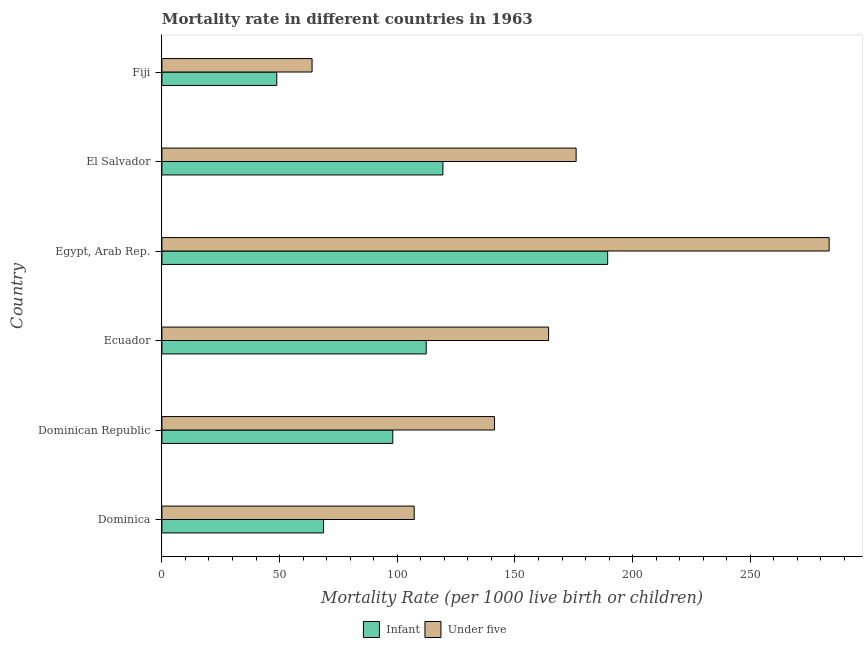How many different coloured bars are there?
Ensure brevity in your answer.  2. How many groups of bars are there?
Give a very brief answer. 6. How many bars are there on the 6th tick from the bottom?
Provide a short and direct response. 2. What is the label of the 1st group of bars from the top?
Provide a succinct answer. Fiji. In how many cases, is the number of bars for a given country not equal to the number of legend labels?
Provide a succinct answer. 0. What is the infant mortality rate in Egypt, Arab Rep.?
Ensure brevity in your answer.  189.4. Across all countries, what is the maximum infant mortality rate?
Your response must be concise. 189.4. Across all countries, what is the minimum under-5 mortality rate?
Your answer should be very brief. 63.8. In which country was the under-5 mortality rate maximum?
Your response must be concise. Egypt, Arab Rep. In which country was the under-5 mortality rate minimum?
Keep it short and to the point. Fiji. What is the total under-5 mortality rate in the graph?
Ensure brevity in your answer.  936.1. What is the difference between the infant mortality rate in Dominican Republic and that in Fiji?
Offer a very short reply. 49.3. What is the difference between the infant mortality rate in Fiji and the under-5 mortality rate in El Salvador?
Your response must be concise. -127.2. What is the average infant mortality rate per country?
Give a very brief answer. 106.12. What is the difference between the infant mortality rate and under-5 mortality rate in Dominica?
Make the answer very short. -38.5. In how many countries, is the infant mortality rate greater than 280 ?
Offer a very short reply. 0. What is the ratio of the under-5 mortality rate in Ecuador to that in Egypt, Arab Rep.?
Your answer should be compact. 0.58. What is the difference between the highest and the second highest infant mortality rate?
Provide a short and direct response. 70. What is the difference between the highest and the lowest under-5 mortality rate?
Make the answer very short. 219.7. Is the sum of the infant mortality rate in Egypt, Arab Rep. and El Salvador greater than the maximum under-5 mortality rate across all countries?
Provide a short and direct response. Yes. What does the 2nd bar from the top in Dominica represents?
Provide a short and direct response. Infant. What does the 1st bar from the bottom in Dominican Republic represents?
Your response must be concise. Infant. What is the difference between two consecutive major ticks on the X-axis?
Keep it short and to the point. 50. Are the values on the major ticks of X-axis written in scientific E-notation?
Make the answer very short. No. Does the graph contain any zero values?
Offer a very short reply. No. How many legend labels are there?
Provide a short and direct response. 2. What is the title of the graph?
Keep it short and to the point. Mortality rate in different countries in 1963. Does "Age 65(male)" appear as one of the legend labels in the graph?
Your answer should be very brief. No. What is the label or title of the X-axis?
Make the answer very short. Mortality Rate (per 1000 live birth or children). What is the Mortality Rate (per 1000 live birth or children) of Infant in Dominica?
Your answer should be very brief. 68.7. What is the Mortality Rate (per 1000 live birth or children) in Under five in Dominica?
Provide a succinct answer. 107.2. What is the Mortality Rate (per 1000 live birth or children) in Infant in Dominican Republic?
Offer a terse response. 98.1. What is the Mortality Rate (per 1000 live birth or children) of Under five in Dominican Republic?
Your answer should be very brief. 141.3. What is the Mortality Rate (per 1000 live birth or children) in Infant in Ecuador?
Your response must be concise. 112.3. What is the Mortality Rate (per 1000 live birth or children) of Under five in Ecuador?
Give a very brief answer. 164.3. What is the Mortality Rate (per 1000 live birth or children) of Infant in Egypt, Arab Rep.?
Your answer should be compact. 189.4. What is the Mortality Rate (per 1000 live birth or children) of Under five in Egypt, Arab Rep.?
Your answer should be very brief. 283.5. What is the Mortality Rate (per 1000 live birth or children) in Infant in El Salvador?
Your answer should be very brief. 119.4. What is the Mortality Rate (per 1000 live birth or children) in Under five in El Salvador?
Your answer should be very brief. 176. What is the Mortality Rate (per 1000 live birth or children) of Infant in Fiji?
Give a very brief answer. 48.8. What is the Mortality Rate (per 1000 live birth or children) of Under five in Fiji?
Provide a short and direct response. 63.8. Across all countries, what is the maximum Mortality Rate (per 1000 live birth or children) in Infant?
Provide a short and direct response. 189.4. Across all countries, what is the maximum Mortality Rate (per 1000 live birth or children) of Under five?
Give a very brief answer. 283.5. Across all countries, what is the minimum Mortality Rate (per 1000 live birth or children) of Infant?
Your answer should be very brief. 48.8. Across all countries, what is the minimum Mortality Rate (per 1000 live birth or children) of Under five?
Keep it short and to the point. 63.8. What is the total Mortality Rate (per 1000 live birth or children) of Infant in the graph?
Offer a very short reply. 636.7. What is the total Mortality Rate (per 1000 live birth or children) of Under five in the graph?
Provide a short and direct response. 936.1. What is the difference between the Mortality Rate (per 1000 live birth or children) in Infant in Dominica and that in Dominican Republic?
Keep it short and to the point. -29.4. What is the difference between the Mortality Rate (per 1000 live birth or children) in Under five in Dominica and that in Dominican Republic?
Keep it short and to the point. -34.1. What is the difference between the Mortality Rate (per 1000 live birth or children) of Infant in Dominica and that in Ecuador?
Ensure brevity in your answer.  -43.6. What is the difference between the Mortality Rate (per 1000 live birth or children) in Under five in Dominica and that in Ecuador?
Ensure brevity in your answer.  -57.1. What is the difference between the Mortality Rate (per 1000 live birth or children) of Infant in Dominica and that in Egypt, Arab Rep.?
Keep it short and to the point. -120.7. What is the difference between the Mortality Rate (per 1000 live birth or children) of Under five in Dominica and that in Egypt, Arab Rep.?
Keep it short and to the point. -176.3. What is the difference between the Mortality Rate (per 1000 live birth or children) in Infant in Dominica and that in El Salvador?
Provide a succinct answer. -50.7. What is the difference between the Mortality Rate (per 1000 live birth or children) of Under five in Dominica and that in El Salvador?
Your answer should be very brief. -68.8. What is the difference between the Mortality Rate (per 1000 live birth or children) of Infant in Dominica and that in Fiji?
Your answer should be compact. 19.9. What is the difference between the Mortality Rate (per 1000 live birth or children) of Under five in Dominica and that in Fiji?
Keep it short and to the point. 43.4. What is the difference between the Mortality Rate (per 1000 live birth or children) in Infant in Dominican Republic and that in Ecuador?
Your answer should be very brief. -14.2. What is the difference between the Mortality Rate (per 1000 live birth or children) in Infant in Dominican Republic and that in Egypt, Arab Rep.?
Your answer should be compact. -91.3. What is the difference between the Mortality Rate (per 1000 live birth or children) in Under five in Dominican Republic and that in Egypt, Arab Rep.?
Ensure brevity in your answer.  -142.2. What is the difference between the Mortality Rate (per 1000 live birth or children) in Infant in Dominican Republic and that in El Salvador?
Your answer should be compact. -21.3. What is the difference between the Mortality Rate (per 1000 live birth or children) of Under five in Dominican Republic and that in El Salvador?
Give a very brief answer. -34.7. What is the difference between the Mortality Rate (per 1000 live birth or children) of Infant in Dominican Republic and that in Fiji?
Offer a terse response. 49.3. What is the difference between the Mortality Rate (per 1000 live birth or children) of Under five in Dominican Republic and that in Fiji?
Offer a terse response. 77.5. What is the difference between the Mortality Rate (per 1000 live birth or children) of Infant in Ecuador and that in Egypt, Arab Rep.?
Give a very brief answer. -77.1. What is the difference between the Mortality Rate (per 1000 live birth or children) in Under five in Ecuador and that in Egypt, Arab Rep.?
Your answer should be compact. -119.2. What is the difference between the Mortality Rate (per 1000 live birth or children) in Infant in Ecuador and that in Fiji?
Keep it short and to the point. 63.5. What is the difference between the Mortality Rate (per 1000 live birth or children) in Under five in Ecuador and that in Fiji?
Provide a succinct answer. 100.5. What is the difference between the Mortality Rate (per 1000 live birth or children) in Infant in Egypt, Arab Rep. and that in El Salvador?
Keep it short and to the point. 70. What is the difference between the Mortality Rate (per 1000 live birth or children) of Under five in Egypt, Arab Rep. and that in El Salvador?
Ensure brevity in your answer.  107.5. What is the difference between the Mortality Rate (per 1000 live birth or children) of Infant in Egypt, Arab Rep. and that in Fiji?
Offer a terse response. 140.6. What is the difference between the Mortality Rate (per 1000 live birth or children) in Under five in Egypt, Arab Rep. and that in Fiji?
Offer a very short reply. 219.7. What is the difference between the Mortality Rate (per 1000 live birth or children) in Infant in El Salvador and that in Fiji?
Make the answer very short. 70.6. What is the difference between the Mortality Rate (per 1000 live birth or children) in Under five in El Salvador and that in Fiji?
Your answer should be compact. 112.2. What is the difference between the Mortality Rate (per 1000 live birth or children) in Infant in Dominica and the Mortality Rate (per 1000 live birth or children) in Under five in Dominican Republic?
Your answer should be compact. -72.6. What is the difference between the Mortality Rate (per 1000 live birth or children) in Infant in Dominica and the Mortality Rate (per 1000 live birth or children) in Under five in Ecuador?
Offer a very short reply. -95.6. What is the difference between the Mortality Rate (per 1000 live birth or children) in Infant in Dominica and the Mortality Rate (per 1000 live birth or children) in Under five in Egypt, Arab Rep.?
Make the answer very short. -214.8. What is the difference between the Mortality Rate (per 1000 live birth or children) of Infant in Dominica and the Mortality Rate (per 1000 live birth or children) of Under five in El Salvador?
Keep it short and to the point. -107.3. What is the difference between the Mortality Rate (per 1000 live birth or children) in Infant in Dominica and the Mortality Rate (per 1000 live birth or children) in Under five in Fiji?
Ensure brevity in your answer.  4.9. What is the difference between the Mortality Rate (per 1000 live birth or children) in Infant in Dominican Republic and the Mortality Rate (per 1000 live birth or children) in Under five in Ecuador?
Provide a succinct answer. -66.2. What is the difference between the Mortality Rate (per 1000 live birth or children) of Infant in Dominican Republic and the Mortality Rate (per 1000 live birth or children) of Under five in Egypt, Arab Rep.?
Your answer should be very brief. -185.4. What is the difference between the Mortality Rate (per 1000 live birth or children) of Infant in Dominican Republic and the Mortality Rate (per 1000 live birth or children) of Under five in El Salvador?
Provide a short and direct response. -77.9. What is the difference between the Mortality Rate (per 1000 live birth or children) in Infant in Dominican Republic and the Mortality Rate (per 1000 live birth or children) in Under five in Fiji?
Offer a very short reply. 34.3. What is the difference between the Mortality Rate (per 1000 live birth or children) of Infant in Ecuador and the Mortality Rate (per 1000 live birth or children) of Under five in Egypt, Arab Rep.?
Your answer should be very brief. -171.2. What is the difference between the Mortality Rate (per 1000 live birth or children) of Infant in Ecuador and the Mortality Rate (per 1000 live birth or children) of Under five in El Salvador?
Keep it short and to the point. -63.7. What is the difference between the Mortality Rate (per 1000 live birth or children) of Infant in Ecuador and the Mortality Rate (per 1000 live birth or children) of Under five in Fiji?
Keep it short and to the point. 48.5. What is the difference between the Mortality Rate (per 1000 live birth or children) in Infant in Egypt, Arab Rep. and the Mortality Rate (per 1000 live birth or children) in Under five in Fiji?
Your answer should be compact. 125.6. What is the difference between the Mortality Rate (per 1000 live birth or children) of Infant in El Salvador and the Mortality Rate (per 1000 live birth or children) of Under five in Fiji?
Your answer should be compact. 55.6. What is the average Mortality Rate (per 1000 live birth or children) of Infant per country?
Provide a short and direct response. 106.12. What is the average Mortality Rate (per 1000 live birth or children) of Under five per country?
Your response must be concise. 156.02. What is the difference between the Mortality Rate (per 1000 live birth or children) of Infant and Mortality Rate (per 1000 live birth or children) of Under five in Dominica?
Offer a very short reply. -38.5. What is the difference between the Mortality Rate (per 1000 live birth or children) of Infant and Mortality Rate (per 1000 live birth or children) of Under five in Dominican Republic?
Your answer should be very brief. -43.2. What is the difference between the Mortality Rate (per 1000 live birth or children) of Infant and Mortality Rate (per 1000 live birth or children) of Under five in Ecuador?
Ensure brevity in your answer.  -52. What is the difference between the Mortality Rate (per 1000 live birth or children) of Infant and Mortality Rate (per 1000 live birth or children) of Under five in Egypt, Arab Rep.?
Provide a succinct answer. -94.1. What is the difference between the Mortality Rate (per 1000 live birth or children) in Infant and Mortality Rate (per 1000 live birth or children) in Under five in El Salvador?
Your response must be concise. -56.6. What is the difference between the Mortality Rate (per 1000 live birth or children) in Infant and Mortality Rate (per 1000 live birth or children) in Under five in Fiji?
Ensure brevity in your answer.  -15. What is the ratio of the Mortality Rate (per 1000 live birth or children) of Infant in Dominica to that in Dominican Republic?
Provide a short and direct response. 0.7. What is the ratio of the Mortality Rate (per 1000 live birth or children) of Under five in Dominica to that in Dominican Republic?
Give a very brief answer. 0.76. What is the ratio of the Mortality Rate (per 1000 live birth or children) in Infant in Dominica to that in Ecuador?
Provide a succinct answer. 0.61. What is the ratio of the Mortality Rate (per 1000 live birth or children) in Under five in Dominica to that in Ecuador?
Make the answer very short. 0.65. What is the ratio of the Mortality Rate (per 1000 live birth or children) in Infant in Dominica to that in Egypt, Arab Rep.?
Give a very brief answer. 0.36. What is the ratio of the Mortality Rate (per 1000 live birth or children) of Under five in Dominica to that in Egypt, Arab Rep.?
Offer a very short reply. 0.38. What is the ratio of the Mortality Rate (per 1000 live birth or children) in Infant in Dominica to that in El Salvador?
Make the answer very short. 0.58. What is the ratio of the Mortality Rate (per 1000 live birth or children) of Under five in Dominica to that in El Salvador?
Keep it short and to the point. 0.61. What is the ratio of the Mortality Rate (per 1000 live birth or children) of Infant in Dominica to that in Fiji?
Offer a very short reply. 1.41. What is the ratio of the Mortality Rate (per 1000 live birth or children) of Under five in Dominica to that in Fiji?
Give a very brief answer. 1.68. What is the ratio of the Mortality Rate (per 1000 live birth or children) in Infant in Dominican Republic to that in Ecuador?
Offer a terse response. 0.87. What is the ratio of the Mortality Rate (per 1000 live birth or children) of Under five in Dominican Republic to that in Ecuador?
Keep it short and to the point. 0.86. What is the ratio of the Mortality Rate (per 1000 live birth or children) of Infant in Dominican Republic to that in Egypt, Arab Rep.?
Make the answer very short. 0.52. What is the ratio of the Mortality Rate (per 1000 live birth or children) in Under five in Dominican Republic to that in Egypt, Arab Rep.?
Provide a succinct answer. 0.5. What is the ratio of the Mortality Rate (per 1000 live birth or children) in Infant in Dominican Republic to that in El Salvador?
Your answer should be compact. 0.82. What is the ratio of the Mortality Rate (per 1000 live birth or children) of Under five in Dominican Republic to that in El Salvador?
Make the answer very short. 0.8. What is the ratio of the Mortality Rate (per 1000 live birth or children) of Infant in Dominican Republic to that in Fiji?
Provide a short and direct response. 2.01. What is the ratio of the Mortality Rate (per 1000 live birth or children) in Under five in Dominican Republic to that in Fiji?
Your response must be concise. 2.21. What is the ratio of the Mortality Rate (per 1000 live birth or children) of Infant in Ecuador to that in Egypt, Arab Rep.?
Your answer should be compact. 0.59. What is the ratio of the Mortality Rate (per 1000 live birth or children) in Under five in Ecuador to that in Egypt, Arab Rep.?
Keep it short and to the point. 0.58. What is the ratio of the Mortality Rate (per 1000 live birth or children) in Infant in Ecuador to that in El Salvador?
Your answer should be very brief. 0.94. What is the ratio of the Mortality Rate (per 1000 live birth or children) of Under five in Ecuador to that in El Salvador?
Offer a very short reply. 0.93. What is the ratio of the Mortality Rate (per 1000 live birth or children) of Infant in Ecuador to that in Fiji?
Your answer should be compact. 2.3. What is the ratio of the Mortality Rate (per 1000 live birth or children) in Under five in Ecuador to that in Fiji?
Offer a terse response. 2.58. What is the ratio of the Mortality Rate (per 1000 live birth or children) of Infant in Egypt, Arab Rep. to that in El Salvador?
Provide a short and direct response. 1.59. What is the ratio of the Mortality Rate (per 1000 live birth or children) of Under five in Egypt, Arab Rep. to that in El Salvador?
Ensure brevity in your answer.  1.61. What is the ratio of the Mortality Rate (per 1000 live birth or children) in Infant in Egypt, Arab Rep. to that in Fiji?
Offer a very short reply. 3.88. What is the ratio of the Mortality Rate (per 1000 live birth or children) in Under five in Egypt, Arab Rep. to that in Fiji?
Make the answer very short. 4.44. What is the ratio of the Mortality Rate (per 1000 live birth or children) in Infant in El Salvador to that in Fiji?
Your answer should be very brief. 2.45. What is the ratio of the Mortality Rate (per 1000 live birth or children) in Under five in El Salvador to that in Fiji?
Your answer should be compact. 2.76. What is the difference between the highest and the second highest Mortality Rate (per 1000 live birth or children) of Under five?
Make the answer very short. 107.5. What is the difference between the highest and the lowest Mortality Rate (per 1000 live birth or children) of Infant?
Your answer should be very brief. 140.6. What is the difference between the highest and the lowest Mortality Rate (per 1000 live birth or children) in Under five?
Keep it short and to the point. 219.7. 